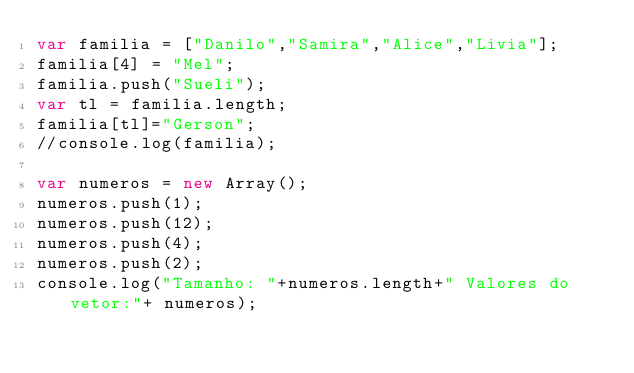Convert code to text. <code><loc_0><loc_0><loc_500><loc_500><_JavaScript_>var familia = ["Danilo","Samira","Alice","Livia"];
familia[4] = "Mel";
familia.push("Sueli");
var tl = familia.length;
familia[tl]="Gerson";
//console.log(familia);

var numeros = new Array();
numeros.push(1);
numeros.push(12);
numeros.push(4);
numeros.push(2);
console.log("Tamanho: "+numeros.length+" Valores do vetor:"+ numeros);






</code> 